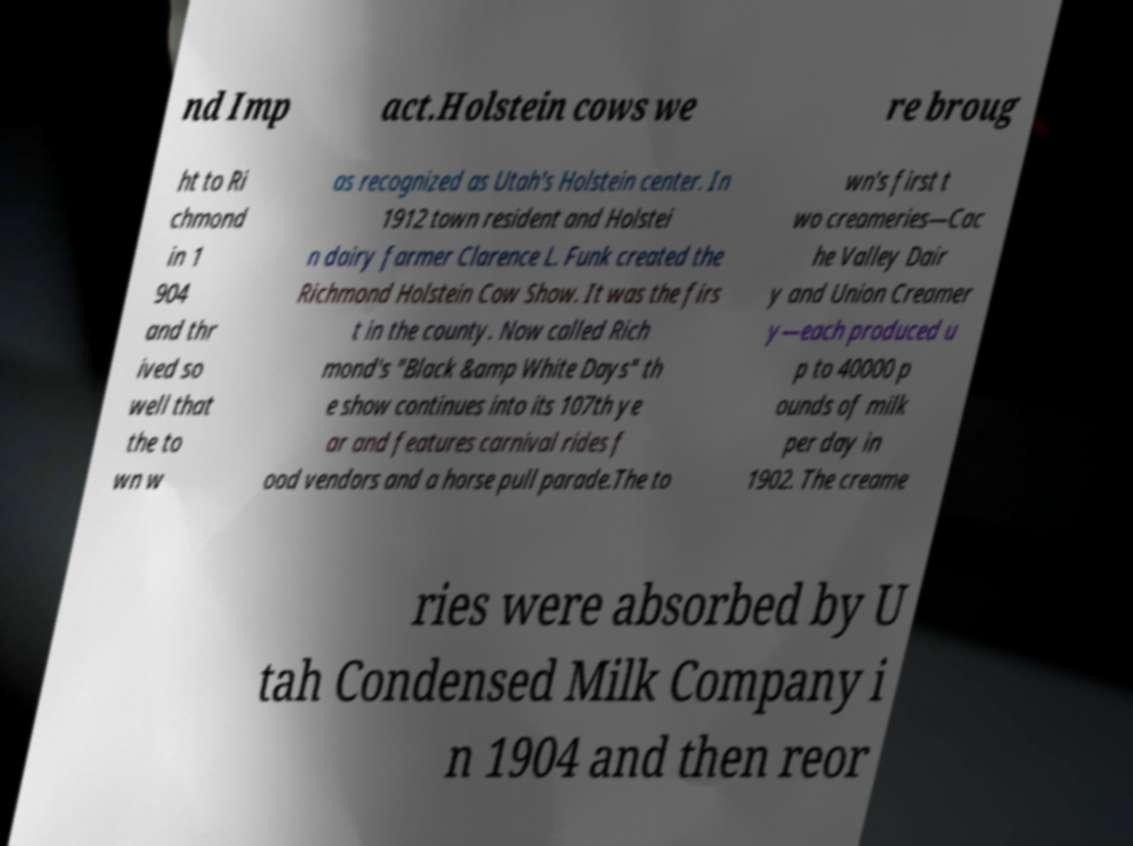Can you accurately transcribe the text from the provided image for me? nd Imp act.Holstein cows we re broug ht to Ri chmond in 1 904 and thr ived so well that the to wn w as recognized as Utah's Holstein center. In 1912 town resident and Holstei n dairy farmer Clarence L. Funk created the Richmond Holstein Cow Show. It was the firs t in the county. Now called Rich mond's "Black &amp White Days" th e show continues into its 107th ye ar and features carnival rides f ood vendors and a horse pull parade.The to wn's first t wo creameries—Cac he Valley Dair y and Union Creamer y—each produced u p to 40000 p ounds of milk per day in 1902. The creame ries were absorbed by U tah Condensed Milk Company i n 1904 and then reor 